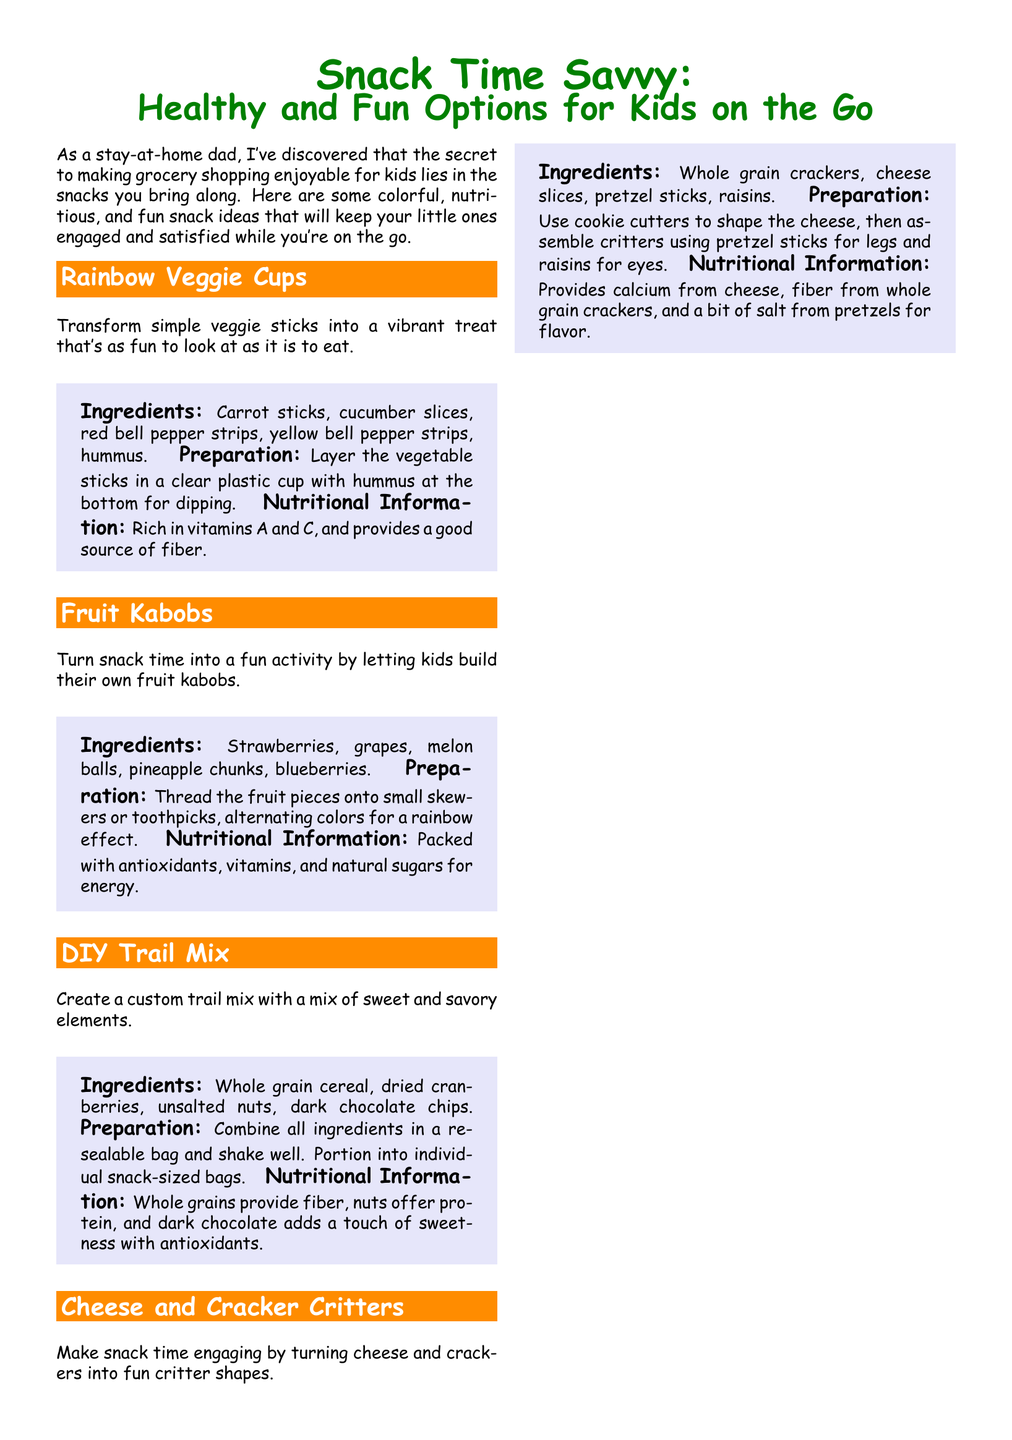What is the first snack idea mentioned? The document lists "Rainbow Veggie Cups" as the first snack option for kids.
Answer: Rainbow Veggie Cups What are the main ingredients for Fruit Kabobs? According to the document, the main ingredients include strawberries, grapes, melon balls, pineapple chunks, and blueberries.
Answer: Strawberries, grapes, melon balls, pineapple chunks, blueberries What nutritional benefit does DIY Trail Mix provide? The document states that DIY Trail Mix offers fiber from whole grains, protein from nuts, and antioxidants from dark chocolate.
Answer: Fiber, protein, antioxidants How should Cheese and Cracker Critters be assembled? Cheese and Cracker Critters should be assembled using cookie cutters, pretzel sticks for legs, and raisins for eyes, as explained in the document.
Answer: Cookie cutters, pretzel sticks, raisins What are two examples of fun packaging ideas mentioned? The document lists colorful bento boxes and themed snack bags as examples of fun packaging ideas for snacks.
Answer: Colorful bento boxes, themed snack bags What vitamins do Rainbow Veggie Cups provide? The document notes that Rainbow Veggie Cups are rich in vitamins A and C.
Answer: Vitamins A and C How should veggie sticks be arranged in Rainbow Veggie Cups? Veggie sticks should be layered in a clear plastic cup with hummus at the bottom, as stated in the document.
Answer: Layered with hummus at the bottom What kind of cheese is suggested for Cheese and Cracker Critters? The document specifically mentions using cheese slices for making the critters.
Answer: Cheese slices How are the DIY Trail Mix ingredients combined? The ingredients for DIY Trail Mix are combined by putting them in a resealable bag and shaking well.
Answer: In a resealable bag and shaking well 